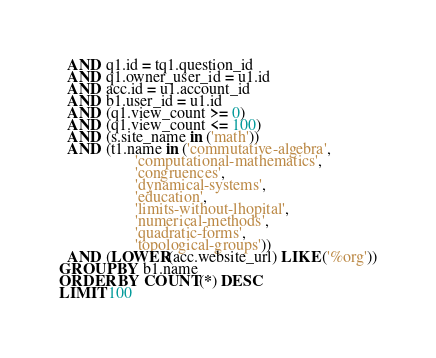Convert code to text. <code><loc_0><loc_0><loc_500><loc_500><_SQL_>  AND q1.id = tq1.question_id
  AND q1.owner_user_id = u1.id
  AND acc.id = u1.account_id
  AND b1.user_id = u1.id
  AND (q1.view_count >= 0)
  AND (q1.view_count <= 100)
  AND (s.site_name in ('math'))
  AND (t1.name in ('commutative-algebra',
                   'computational-mathematics',
                   'congruences',
                   'dynamical-systems',
                   'education',
                   'limits-without-lhopital',
                   'numerical-methods',
                   'quadratic-forms',
                   'topological-groups'))
  AND (LOWER(acc.website_url) LIKE ('%org'))
GROUP BY b1.name
ORDER BY COUNT(*) DESC
LIMIT 100</code> 